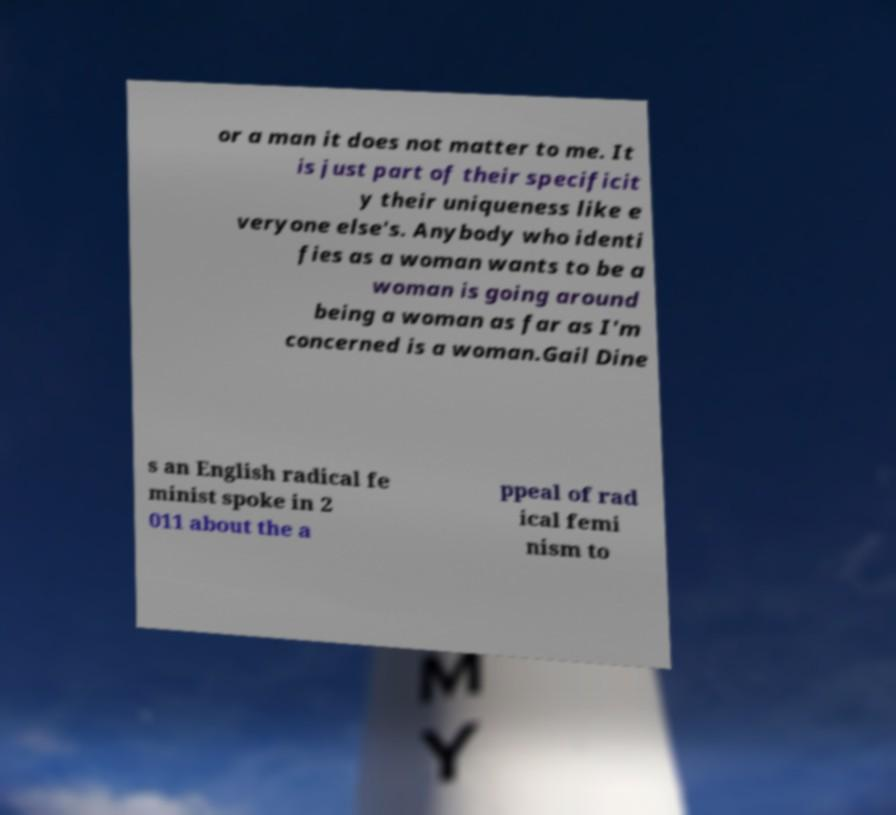There's text embedded in this image that I need extracted. Can you transcribe it verbatim? or a man it does not matter to me. It is just part of their specificit y their uniqueness like e veryone else's. Anybody who identi fies as a woman wants to be a woman is going around being a woman as far as I'm concerned is a woman.Gail Dine s an English radical fe minist spoke in 2 011 about the a ppeal of rad ical femi nism to 